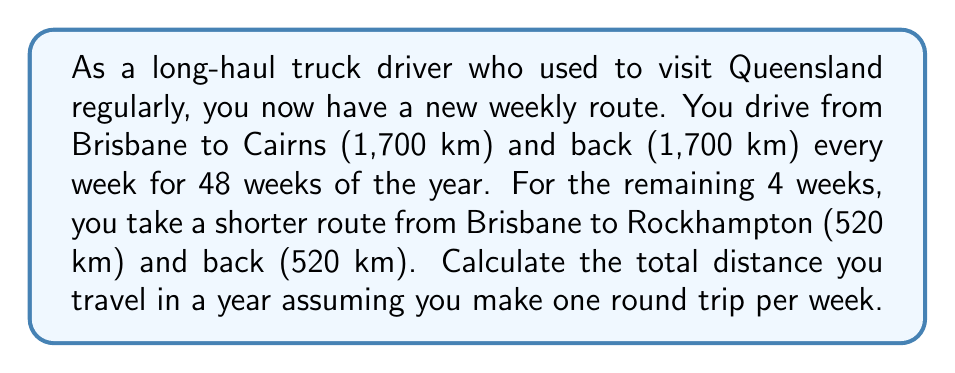Provide a solution to this math problem. Let's break this problem down into steps:

1. Calculate the distance for the longer route (Brisbane to Cairns and back):
   $$d_1 = 1,700 \text{ km} + 1,700 \text{ km} = 3,400 \text{ km per week}$$

2. Calculate the total distance for the longer route over 48 weeks:
   $$D_1 = 3,400 \text{ km} \times 48 \text{ weeks} = 163,200 \text{ km}$$

3. Calculate the distance for the shorter route (Brisbane to Rockhampton and back):
   $$d_2 = 520 \text{ km} + 520 \text{ km} = 1,040 \text{ km per week}$$

4. Calculate the total distance for the shorter route over 4 weeks:
   $$D_2 = 1,040 \text{ km} \times 4 \text{ weeks} = 4,160 \text{ km}$$

5. Sum up the total distance for the year:
   $$D_{total} = D_1 + D_2 = 163,200 \text{ km} + 4,160 \text{ km} = 167,360 \text{ km}$$

Therefore, the total distance traveled in a year is 167,360 km.
Answer: $167,360 \text{ km}$ 